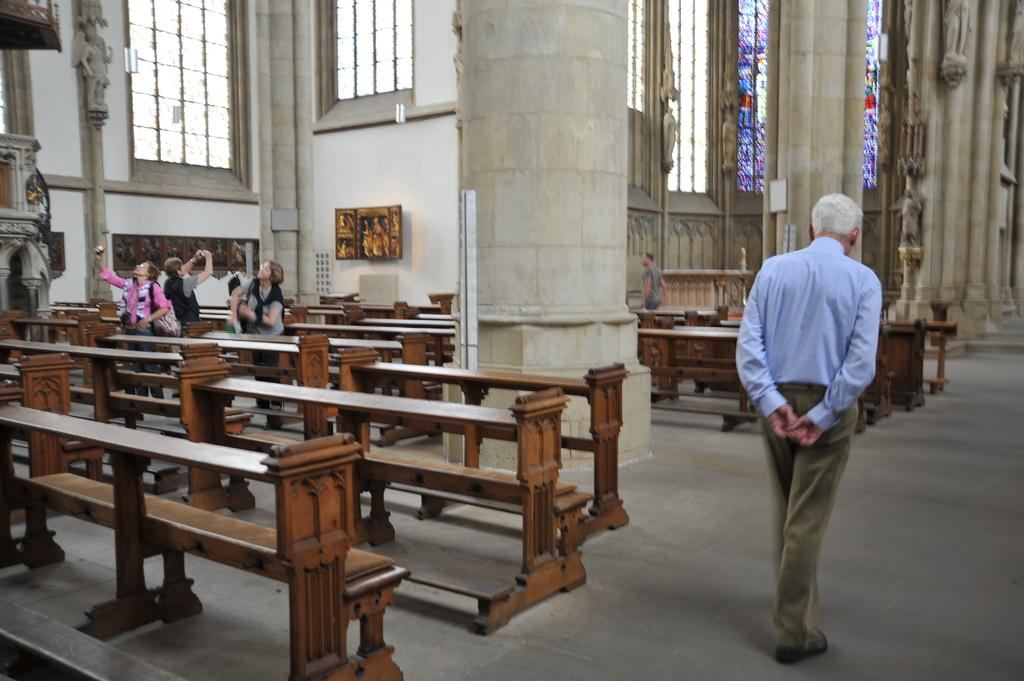What is the color of the wall in the image? The wall in the image is white. What can be seen hanging on the wall? There is a photo frame in the image. What type of furniture is present in the image? There are benches in the image. What is the man in the image doing? A man is walking in the image. What type of cake is being served in the image? There is no cake present in the image. What agreement was reached between the man and the woman in the image? There is no woman or agreement mentioned in the image; it only shows a man walking. 